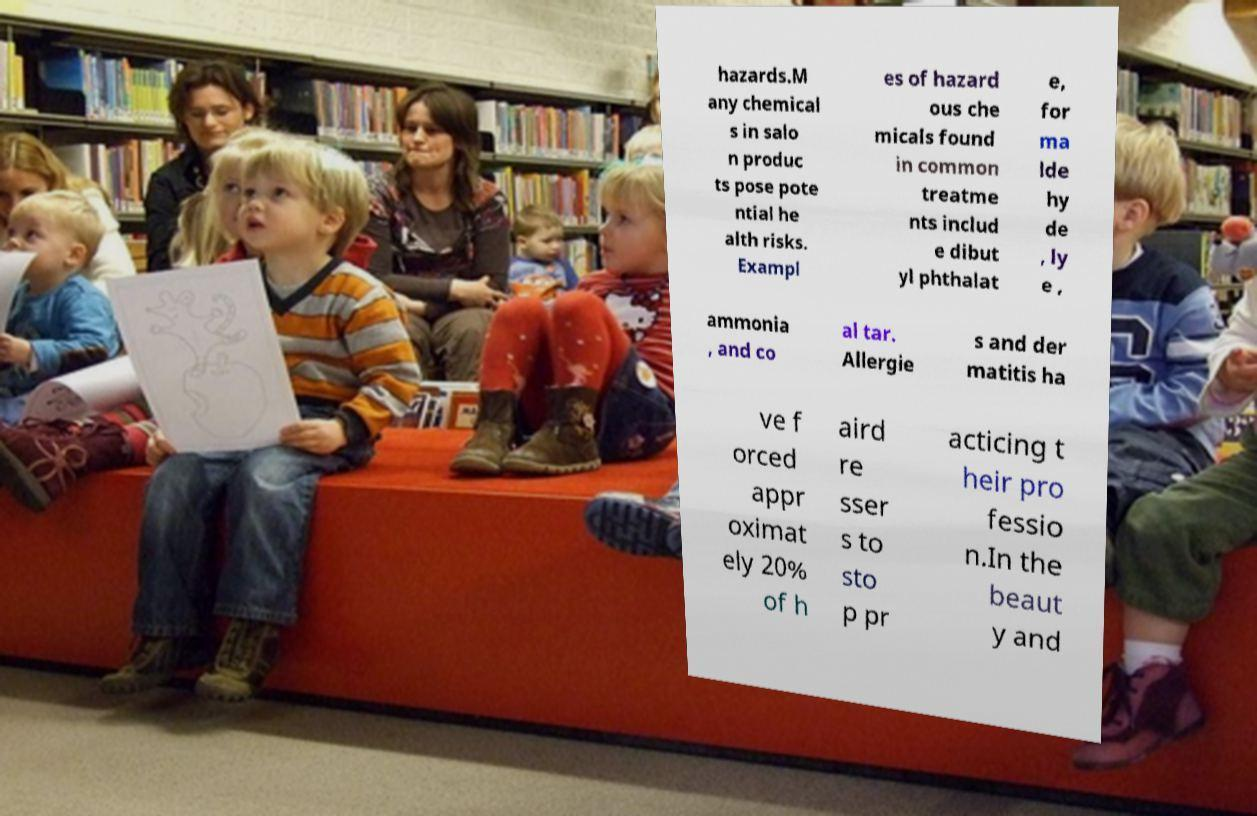There's text embedded in this image that I need extracted. Can you transcribe it verbatim? hazards.M any chemical s in salo n produc ts pose pote ntial he alth risks. Exampl es of hazard ous che micals found in common treatme nts includ e dibut yl phthalat e, for ma lde hy de , ly e , ammonia , and co al tar. Allergie s and der matitis ha ve f orced appr oximat ely 20% of h aird re sser s to sto p pr acticing t heir pro fessio n.In the beaut y and 